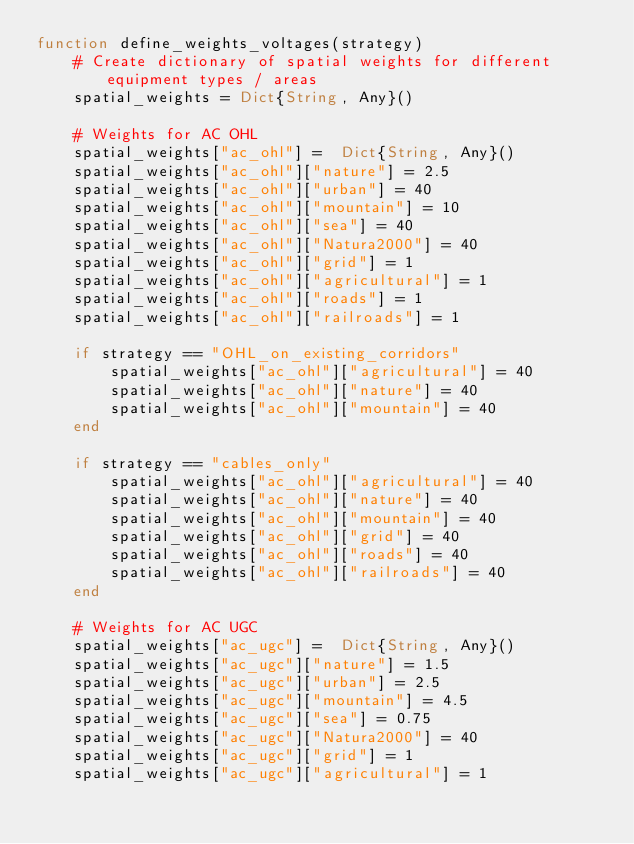Convert code to text. <code><loc_0><loc_0><loc_500><loc_500><_Julia_>function define_weights_voltages(strategy)
    # Create dictionary of spatial weights for different equipment types / areas
    spatial_weights = Dict{String, Any}()

    # Weights for AC OHL
    spatial_weights["ac_ohl"] =  Dict{String, Any}()
    spatial_weights["ac_ohl"]["nature"] = 2.5
    spatial_weights["ac_ohl"]["urban"] = 40
    spatial_weights["ac_ohl"]["mountain"] = 10
    spatial_weights["ac_ohl"]["sea"] = 40
    spatial_weights["ac_ohl"]["Natura2000"] = 40
    spatial_weights["ac_ohl"]["grid"] = 1
    spatial_weights["ac_ohl"]["agricultural"] = 1
    spatial_weights["ac_ohl"]["roads"] = 1
    spatial_weights["ac_ohl"]["railroads"] = 1

    if strategy == "OHL_on_existing_corridors"
        spatial_weights["ac_ohl"]["agricultural"] = 40
        spatial_weights["ac_ohl"]["nature"] = 40
        spatial_weights["ac_ohl"]["mountain"] = 40
    end

    if strategy == "cables_only"
        spatial_weights["ac_ohl"]["agricultural"] = 40
        spatial_weights["ac_ohl"]["nature"] = 40
        spatial_weights["ac_ohl"]["mountain"] = 40
        spatial_weights["ac_ohl"]["grid"] = 40
        spatial_weights["ac_ohl"]["roads"] = 40
        spatial_weights["ac_ohl"]["railroads"] = 40
    end

    # Weights for AC UGC
    spatial_weights["ac_ugc"] =  Dict{String, Any}()
    spatial_weights["ac_ugc"]["nature"] = 1.5
    spatial_weights["ac_ugc"]["urban"] = 2.5
    spatial_weights["ac_ugc"]["mountain"] = 4.5
    spatial_weights["ac_ugc"]["sea"] = 0.75
    spatial_weights["ac_ugc"]["Natura2000"] = 40
    spatial_weights["ac_ugc"]["grid"] = 1
    spatial_weights["ac_ugc"]["agricultural"] = 1</code> 